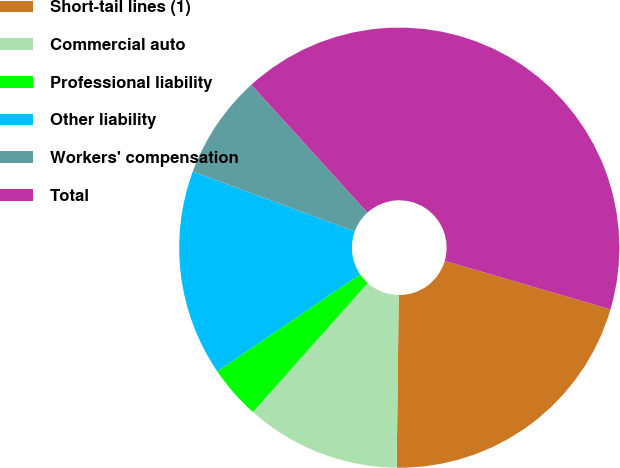Convert chart. <chart><loc_0><loc_0><loc_500><loc_500><pie_chart><fcel>Short-tail lines (1)<fcel>Commercial auto<fcel>Professional liability<fcel>Other liability<fcel>Workers' compensation<fcel>Total<nl><fcel>20.67%<fcel>11.39%<fcel>3.92%<fcel>15.12%<fcel>7.65%<fcel>41.25%<nl></chart> 